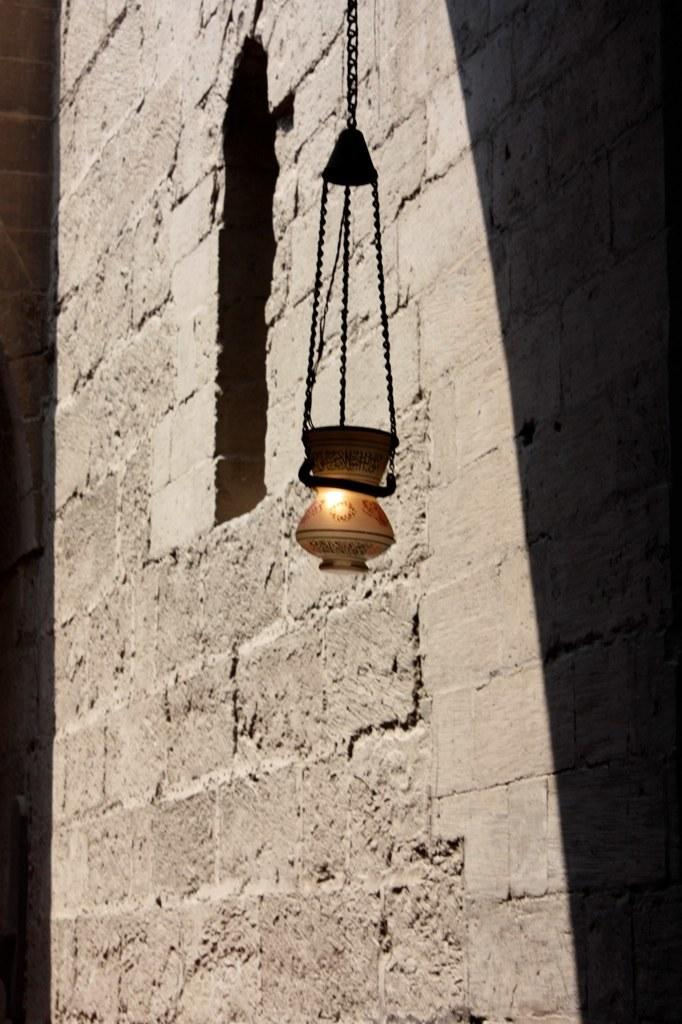What type of structure is visible in the image? There is a brick wall in the image. What is attached to the brick wall with a chain? There is an object hanging with a chain in the image. Can you describe the light in the image? There is a light in the image. Where is the waste or error located in the image? There is no waste or error present in the image. Can you see a nest in the image? There is no nest present in the image. 